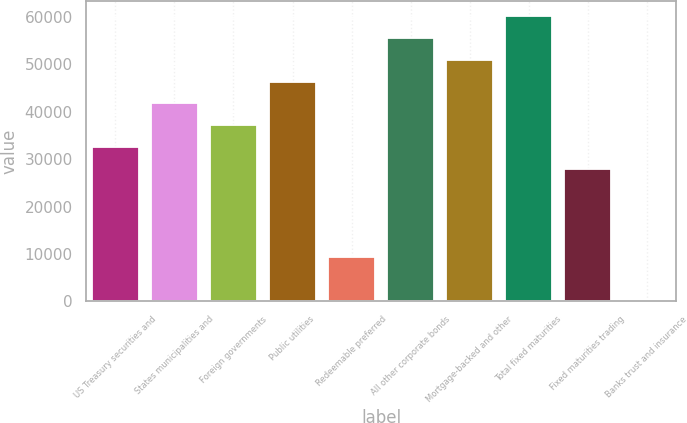Convert chart to OTSL. <chart><loc_0><loc_0><loc_500><loc_500><bar_chart><fcel>US Treasury securities and<fcel>States municipalities and<fcel>Foreign governments<fcel>Public utilities<fcel>Redeemable preferred<fcel>All other corporate bonds<fcel>Mortgage-backed and other<fcel>Total fixed maturities<fcel>Fixed maturities trading<fcel>Banks trust and insurance<nl><fcel>32487.5<fcel>41768.3<fcel>37127.9<fcel>46408.7<fcel>9285.42<fcel>55689.5<fcel>51049.1<fcel>60329.9<fcel>27847.1<fcel>4.6<nl></chart> 